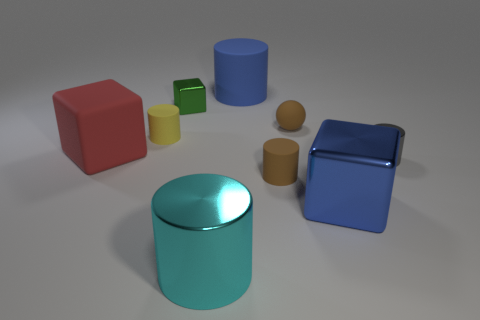Subtract all rubber cylinders. How many cylinders are left? 2 Subtract all gray cylinders. How many cylinders are left? 4 Subtract 1 blocks. How many blocks are left? 2 Add 1 blue things. How many objects exist? 10 Subtract all balls. How many objects are left? 8 Subtract all gray cylinders. Subtract all purple cubes. How many cylinders are left? 4 Subtract all yellow matte things. Subtract all cylinders. How many objects are left? 3 Add 9 large rubber cylinders. How many large rubber cylinders are left? 10 Add 6 tiny cyan metallic objects. How many tiny cyan metallic objects exist? 6 Subtract 0 gray balls. How many objects are left? 9 